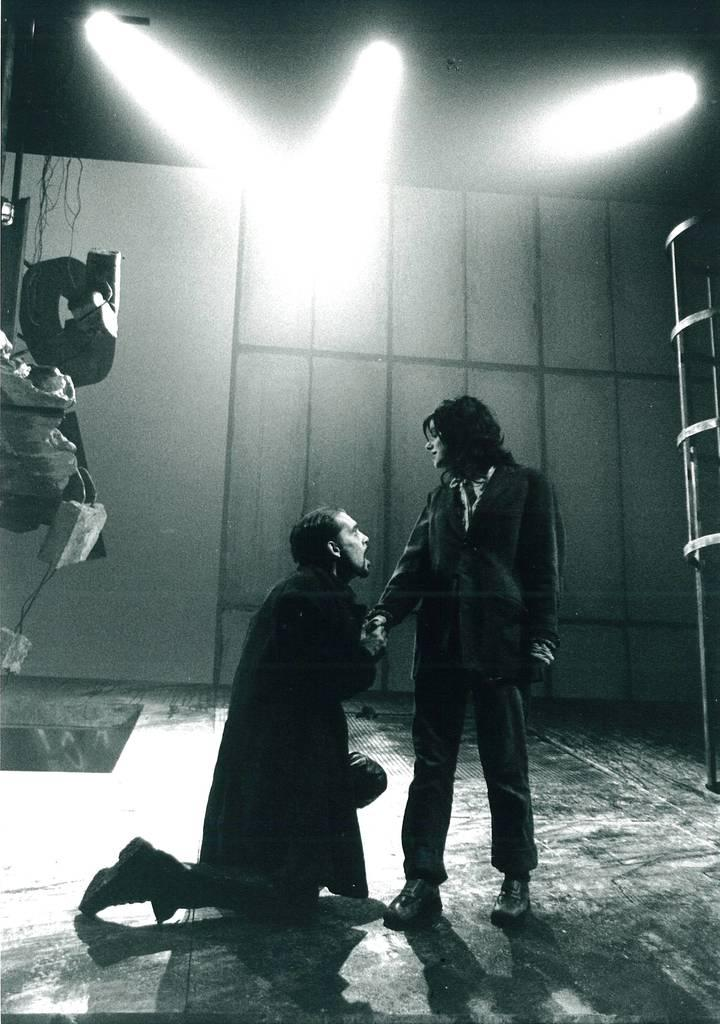How many people are in the image? There are two people in the image. What can be seen in the image besides the people? There are lights and objects visible in the image. What is the color scheme of the image? The image is in black and white. What type of growth can be seen on the truck in the image? There is no truck present in the image, and therefore no growth can be observed. 